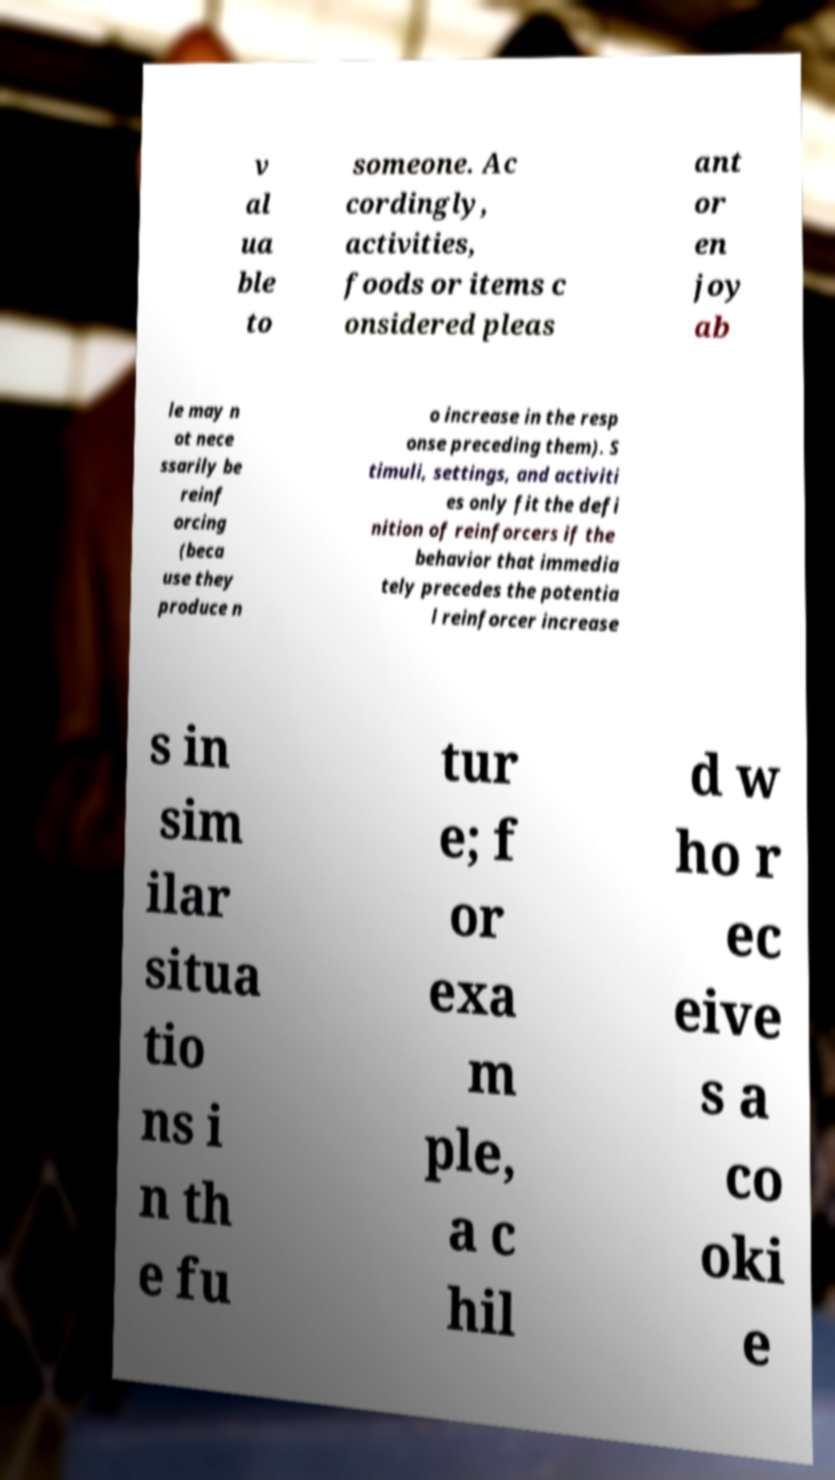For documentation purposes, I need the text within this image transcribed. Could you provide that? v al ua ble to someone. Ac cordingly, activities, foods or items c onsidered pleas ant or en joy ab le may n ot nece ssarily be reinf orcing (beca use they produce n o increase in the resp onse preceding them). S timuli, settings, and activiti es only fit the defi nition of reinforcers if the behavior that immedia tely precedes the potentia l reinforcer increase s in sim ilar situa tio ns i n th e fu tur e; f or exa m ple, a c hil d w ho r ec eive s a co oki e 